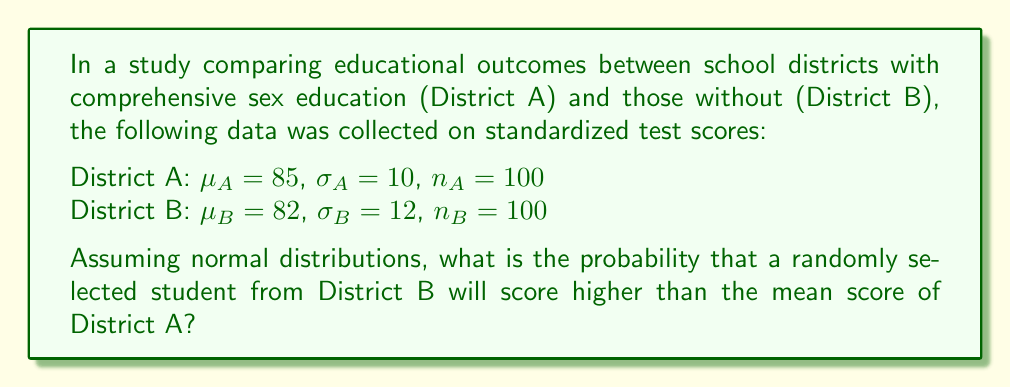Provide a solution to this math problem. To solve this problem, we'll use the properties of normal distributions and the z-score formula.

1) We need to find the z-score for the mean of District A ($\mu_A$) relative to District B's distribution:

   $z = \frac{x - \mu_B}{\sigma_B} = \frac{85 - 82}{12} = 0.25$

2) This z-score represents the number of standard deviations that $\mu_A$ is above $\mu_B$.

3) To find the probability that a student from District B scores higher than $\mu_A$, we need to find the area to the right of this z-score on a standard normal distribution.

4) Using a standard normal table or calculator, we find:

   $P(Z > 0.25) = 1 - P(Z \leq 0.25) = 1 - 0.5987 = 0.4013$

5) Therefore, the probability is approximately 0.4013 or 40.13%.

This result suggests that despite the absence of comprehensive sex education, students from District B still have a substantial chance (about 40%) of outperforming the average student from District A on standardized tests.
Answer: 0.4013 